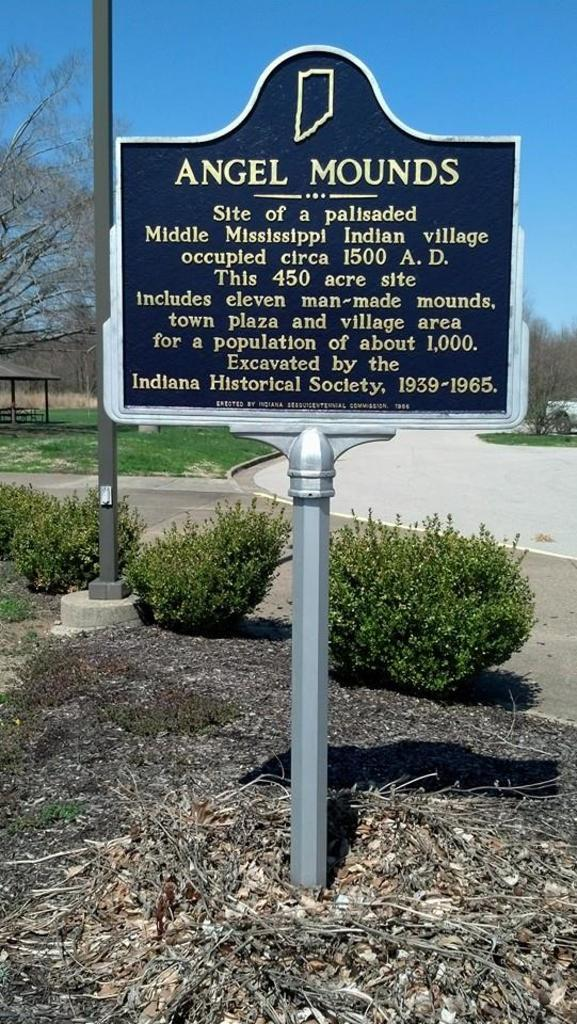What is located in the center of the image? There is a board on the ground in the center of the image. What can be seen in the background of the image? There are trees, a pole, plants, a road, and the sky visible in the background of the image. How far away is the person playing volleyball in the image? There is no person playing volleyball present in the image. What type of distance is being measured in the image? The image does not depict any distance being measured. 